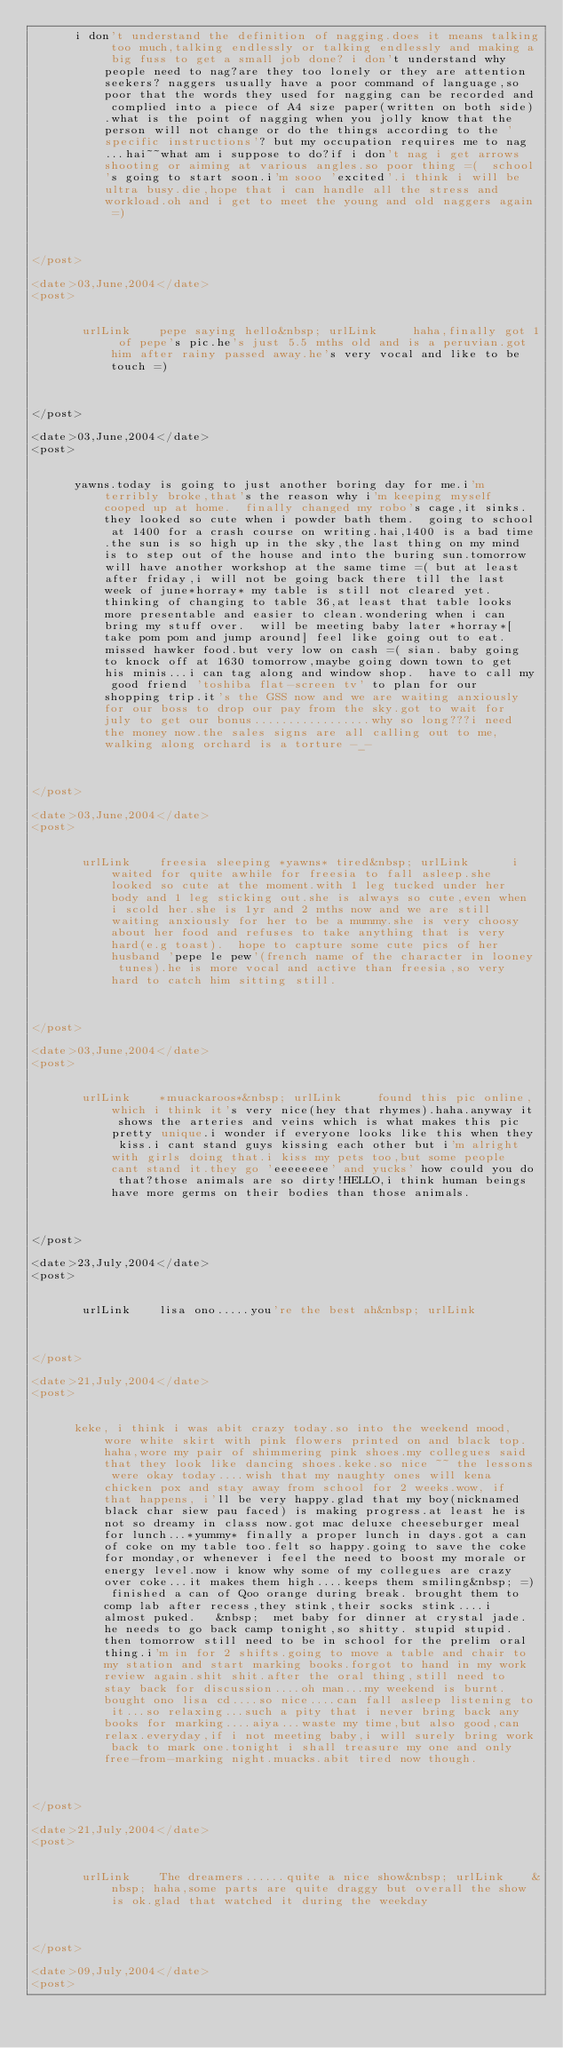Convert code to text. <code><loc_0><loc_0><loc_500><loc_500><_XML_>      i don't understand the definition of nagging.does it means talking too much,talking endlessly or talking endlessly and making a big fuss to get a small job done? i don't understand why people need to nag?are they too lonely or they are attention seekers? naggers usually have a poor command of language,so poor that the words they used for nagging can be recorded and complied into a piece of A4 size paper(written on both side).what is the point of nagging when you jolly know that the person will not change or do the things according to the 'specific instructions'? but my occupation requires me to nag...hai~~what am i suppose to do?if i don't nag i get arrows shooting or aiming at various angles.so poor thing =(  school's going to start soon.i'm sooo 'excited'.i think i will be ultra busy.die,hope that i can handle all the stress and workload.oh and i get to meet the young and old naggers again =)   
     

    
</post>

<date>03,June,2004</date>
<post>

	 
       urlLink    pepe saying hello&nbsp; urlLink     haha,finally got 1 of pepe's pic.he's just 5.5 mths old and is a peruvian.got him after rainy passed away.he's very vocal and like to be touch =)
     

    
</post>

<date>03,June,2004</date>
<post>

	 
      yawns.today is going to just another boring day for me.i'm terribly broke,that's the reason why i'm keeping myself cooped up at home.  finally changed my robo's cage,it sinks.they looked so cute when i powder bath them.  going to school at 1400 for a crash course on writing.hai,1400 is a bad time.the sun is so high up in the sky,the last thing on my mind is to step out of the house and into the buring sun.tomorrow will have another workshop at the same time =( but at least after friday,i will not be going back there till the last week of june*horray* my table is still not cleared yet.thinking of changing to table 36,at least that table looks more presentable and easier to clean.wondering when i can bring my stuff over.  will be meeting baby later *horray*[take pom pom and jump around] feel like going out to eat.missed hawker food.but very low on cash =( sian. baby going to knock off at 1630 tomorrow,maybe going down town to get his minis...i can tag along and window shop.  have to call my good friend 'toshiba flat-screen tv' to plan for our shopping trip.it's the GSS now and we are waiting anxiously for our boss to drop our pay from the sky.got to wait for july to get our bonus.................why so long???i need the money now.the sales signs are all calling out to me,walking along orchard is a torture -_-
     

    
</post>

<date>03,June,2004</date>
<post>

	 
       urlLink    freesia sleeping *yawns* tired&nbsp; urlLink      i waited for quite awhile for freesia to fall asleep.she looked so cute at the moment.with 1 leg tucked under her body and 1 leg sticking out.she is always so cute,even when i scold her.she is 1yr and 2 mths now and we are still waiting anxiously for her to be a mummy.she is very choosy about her food and refuses to take anything that is very hard(e.g toast).  hope to capture some cute pics of her husband 'pepe le pew'(french name of the character in looney tunes).he is more vocal and active than freesia,so very hard to catch him sitting still.
     

    
</post>

<date>03,June,2004</date>
<post>

	 
       urlLink    *muackaroos*&nbsp; urlLink     found this pic online,which i think it's very nice(hey that rhymes).haha.anyway it shows the arteries and veins which is what makes this pic pretty unique.i wonder if everyone looks like this when they kiss.i cant stand guys kissing each other but i'm alright with girls doing that.i kiss my pets too,but some people cant stand it.they go 'eeeeeeee' and yucks' how could you do that?those animals are so dirty!HELLO,i think human beings have more germs on their bodies than those animals.
     

    
</post>

<date>23,July,2004</date>
<post>

	 
       urlLink    lisa ono.....you're the best ah&nbsp; urlLink   
     

    
</post>

<date>21,July,2004</date>
<post>

	 
      keke, i think i was abit crazy today.so into the weekend mood, wore white skirt with pink flowers printed on and black top.haha,wore my pair of shimmering pink shoes.my collegues said that they look like dancing shoes.keke.so nice ~~ the lessons were okay today....wish that my naughty ones will kena chicken pox and stay away from school for 2 weeks.wow, if that happens, i'll be very happy.glad that my boy(nicknamed black char siew pau faced) is making progress.at least he is not so dreamy in class now.got mac deluxe cheeseburger meal for lunch...*yummy* finally a proper lunch in days.got a can of coke on my table too.felt so happy.going to save the coke for monday,or whenever i feel the need to boost my morale or energy level.now i know why some of my collegues are crazy over coke...it makes them high....keeps them smiling&nbsp; =) finished a can of Qoo orange during break. brought them to comp lab after recess,they stink,their socks stink....i almost puked.   &nbsp;  met baby for dinner at crystal jade.he needs to go back camp tonight,so shitty. stupid stupid.then tomorrow still need to be in school for the prelim oral thing.i'm in for 2 shifts.going to move a table and chair to my station and start marking books.forgot to hand in my work review again.shit shit.after the oral thing,still need to stay back for discussion....oh man...my weekend is burnt.bought ono lisa cd....so nice....can fall asleep listening to it...so relaxing...such a pity that i never bring back any books for marking....aiya...waste my time,but also good,can relax.everyday,if i not meeting baby,i will surely bring work back to mark one.tonight i shall treasure my one and only free-from-marking night.muacks.abit tired now though.      
     

    
</post>

<date>21,July,2004</date>
<post>

	 
       urlLink    The dreamers......quite a nice show&nbsp; urlLink    &nbsp; haha,some parts are quite draggy but overall the show is ok.glad that watched it during the weekday 
     

    
</post>

<date>09,July,2004</date>
<post>

	 </code> 